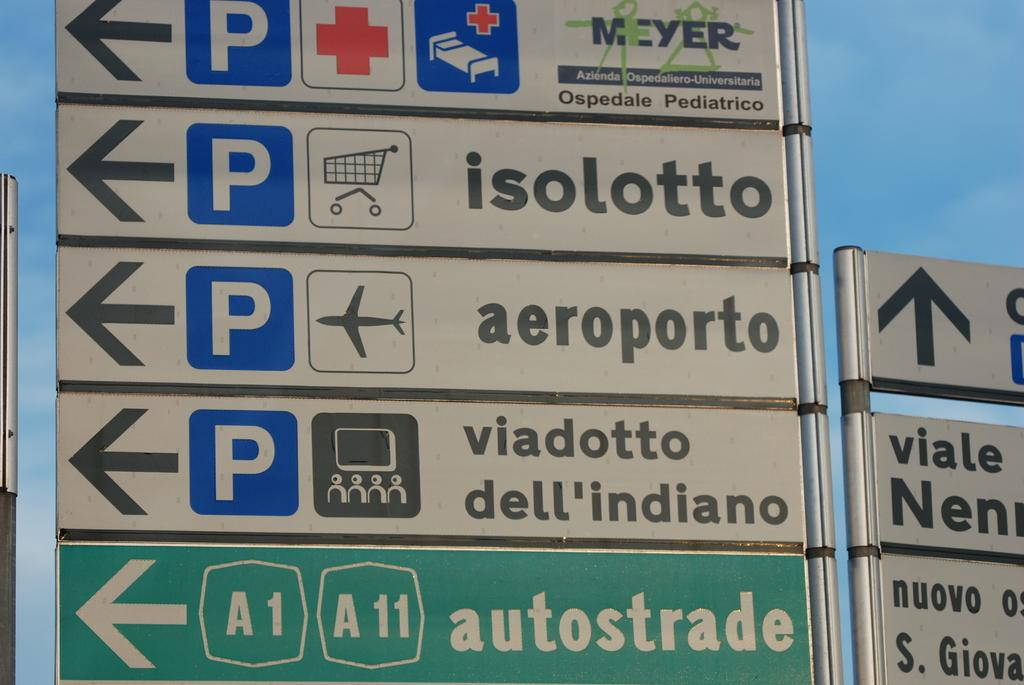<image>
Summarize the visual content of the image. White sign that says aeroporto under a sign that says isolott. 